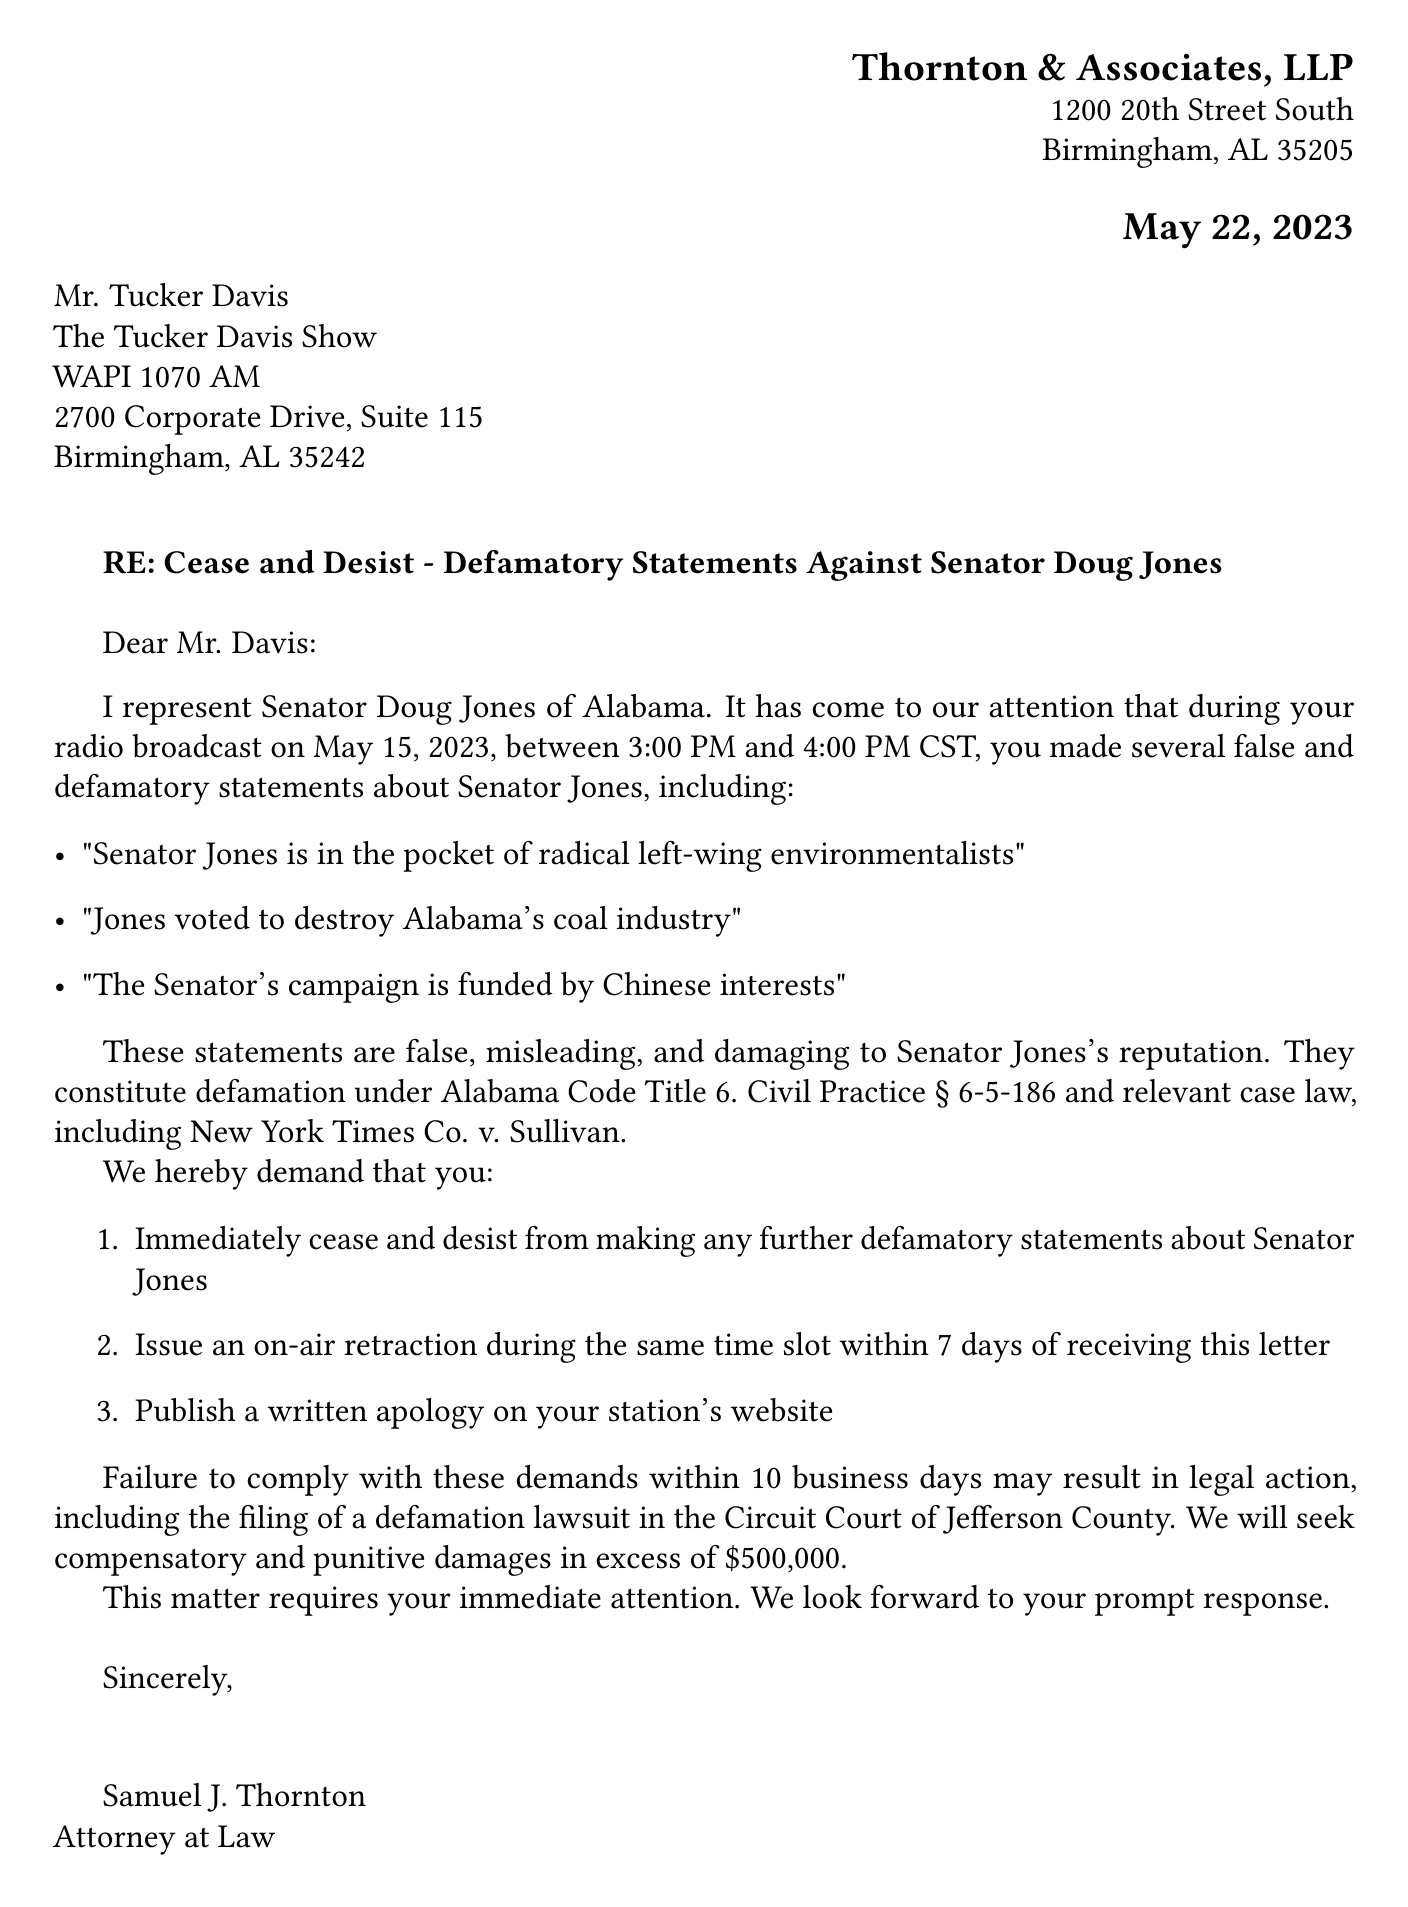What is the date of the broadcast? The broadcast date mentioned in the document is May 15, 2023.
Answer: May 15, 2023 Who is the sender of the letter? The sender's name mentioned in the document is Samuel J. Thornton.
Answer: Samuel J. Thornton What is the specific statute cited in the cease and desist letter? The document cites Alabama Code Title 6. Civil Practice § 6-5-186.
Answer: Alabama Code Title 6. Civil Practice § 6-5-186 What is the time frame for the on-air retraction request? The letter demands an on-air retraction be issued within 7 days.
Answer: 7 days What is the consequence of failing to comply with the demands? The letter states that failure to comply may result in legal action, including the filing of a defamation lawsuit.
Answer: Legal action Which political party does Senator Doug Jones belong to? The document specifies that Senator Doug Jones is a Democrat.
Answer: Democratic 